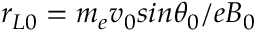Convert formula to latex. <formula><loc_0><loc_0><loc_500><loc_500>r _ { L 0 } = m _ { e } v _ { 0 } \sin \theta _ { 0 } / e B _ { 0 }</formula> 